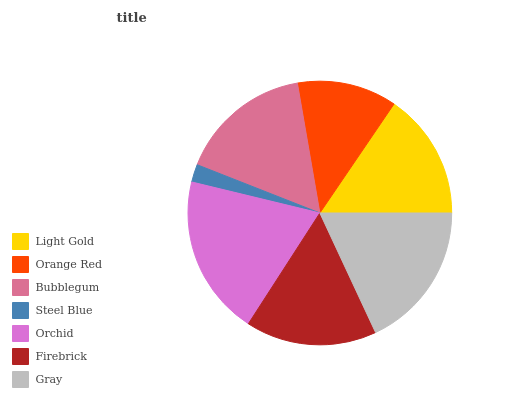Is Steel Blue the minimum?
Answer yes or no. Yes. Is Orchid the maximum?
Answer yes or no. Yes. Is Orange Red the minimum?
Answer yes or no. No. Is Orange Red the maximum?
Answer yes or no. No. Is Light Gold greater than Orange Red?
Answer yes or no. Yes. Is Orange Red less than Light Gold?
Answer yes or no. Yes. Is Orange Red greater than Light Gold?
Answer yes or no. No. Is Light Gold less than Orange Red?
Answer yes or no. No. Is Firebrick the high median?
Answer yes or no. Yes. Is Firebrick the low median?
Answer yes or no. Yes. Is Gray the high median?
Answer yes or no. No. Is Orange Red the low median?
Answer yes or no. No. 